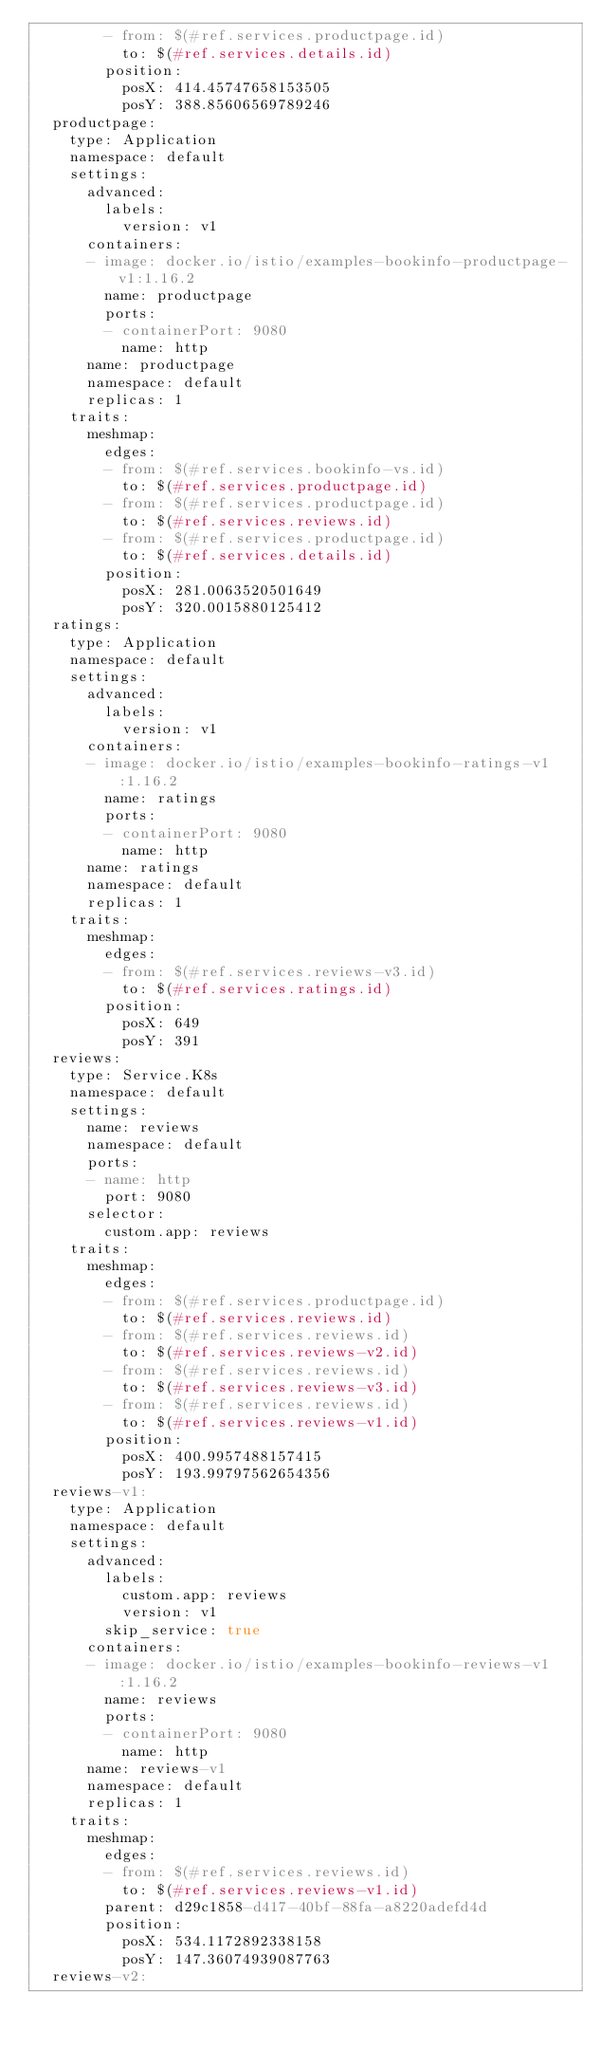Convert code to text. <code><loc_0><loc_0><loc_500><loc_500><_YAML_>        - from: $(#ref.services.productpage.id)
          to: $(#ref.services.details.id)
        position:
          posX: 414.45747658153505
          posY: 388.85606569789246
  productpage:
    type: Application
    namespace: default
    settings:
      advanced:
        labels:
          version: v1
      containers:
      - image: docker.io/istio/examples-bookinfo-productpage-v1:1.16.2
        name: productpage
        ports:
        - containerPort: 9080
          name: http
      name: productpage
      namespace: default
      replicas: 1
    traits:
      meshmap:
        edges:
        - from: $(#ref.services.bookinfo-vs.id)
          to: $(#ref.services.productpage.id)
        - from: $(#ref.services.productpage.id)
          to: $(#ref.services.reviews.id)
        - from: $(#ref.services.productpage.id)
          to: $(#ref.services.details.id)
        position:
          posX: 281.0063520501649
          posY: 320.0015880125412
  ratings:
    type: Application
    namespace: default
    settings:
      advanced:
        labels:
          version: v1
      containers:
      - image: docker.io/istio/examples-bookinfo-ratings-v1:1.16.2
        name: ratings
        ports:
        - containerPort: 9080
          name: http
      name: ratings
      namespace: default
      replicas: 1
    traits:
      meshmap:
        edges:
        - from: $(#ref.services.reviews-v3.id)
          to: $(#ref.services.ratings.id)
        position:
          posX: 649
          posY: 391
  reviews:
    type: Service.K8s
    namespace: default
    settings:
      name: reviews
      namespace: default
      ports:
      - name: http
        port: 9080
      selector:
        custom.app: reviews
    traits:
      meshmap:
        edges:
        - from: $(#ref.services.productpage.id)
          to: $(#ref.services.reviews.id)
        - from: $(#ref.services.reviews.id)
          to: $(#ref.services.reviews-v2.id)
        - from: $(#ref.services.reviews.id)
          to: $(#ref.services.reviews-v3.id)
        - from: $(#ref.services.reviews.id)
          to: $(#ref.services.reviews-v1.id)
        position:
          posX: 400.9957488157415
          posY: 193.99797562654356
  reviews-v1:
    type: Application
    namespace: default
    settings:
      advanced:
        labels:
          custom.app: reviews
          version: v1
        skip_service: true
      containers:
      - image: docker.io/istio/examples-bookinfo-reviews-v1:1.16.2
        name: reviews
        ports:
        - containerPort: 9080
          name: http
      name: reviews-v1
      namespace: default
      replicas: 1
    traits:
      meshmap:
        edges:
        - from: $(#ref.services.reviews.id)
          to: $(#ref.services.reviews-v1.id)
        parent: d29c1858-d417-40bf-88fa-a8220adefd4d
        position:
          posX: 534.1172892338158
          posY: 147.36074939087763
  reviews-v2:</code> 